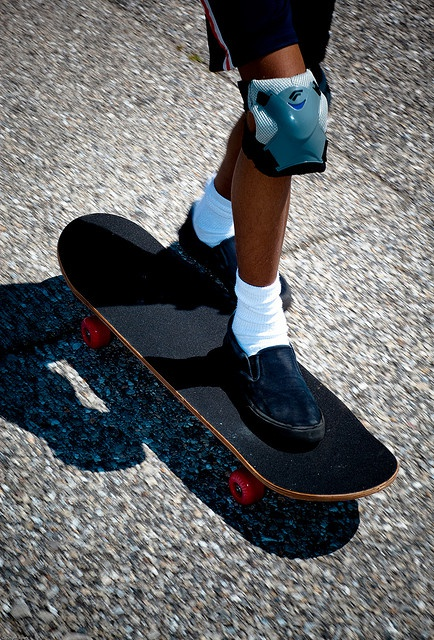Describe the objects in this image and their specific colors. I can see people in gray, black, maroon, darkblue, and lightblue tones and skateboard in gray, black, darkblue, and maroon tones in this image. 